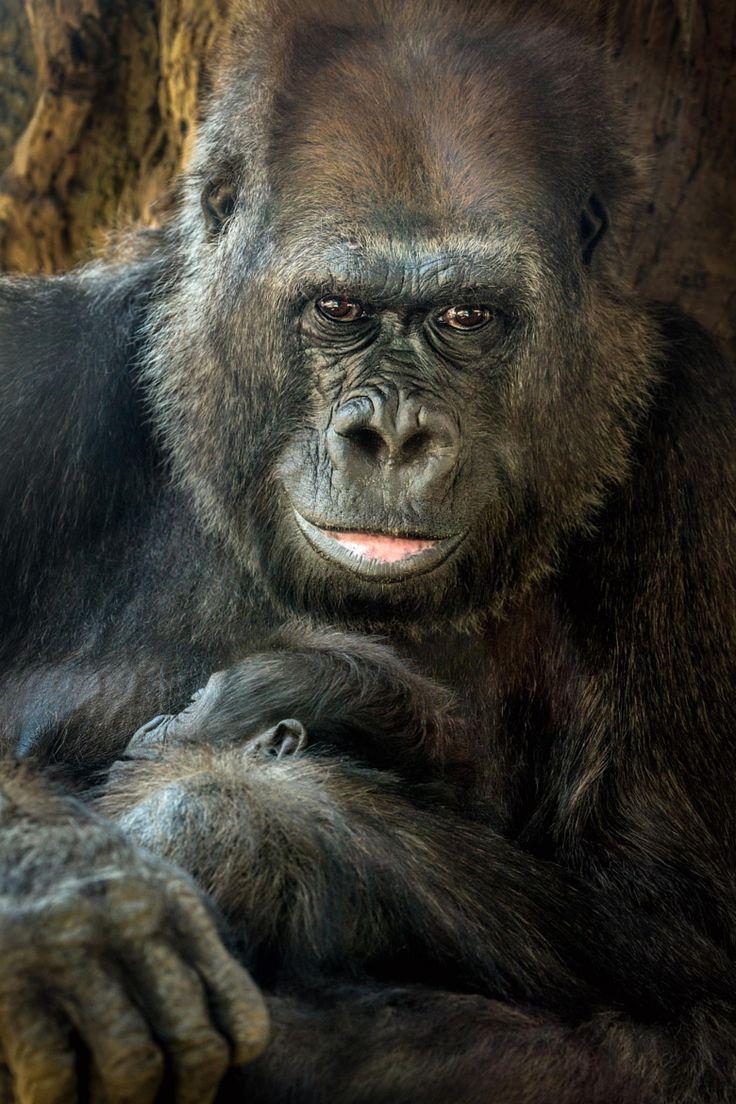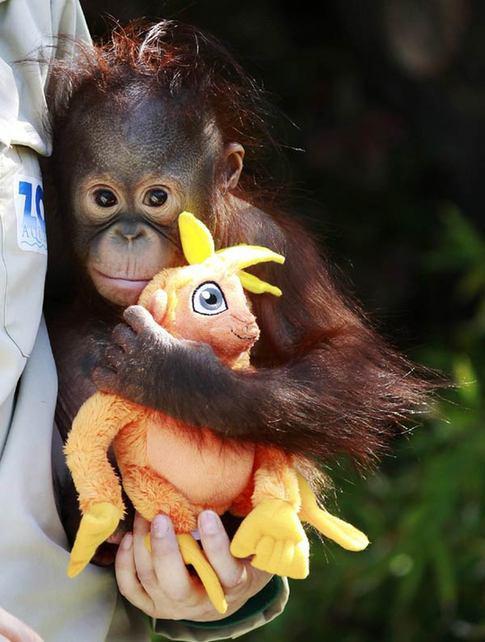The first image is the image on the left, the second image is the image on the right. Considering the images on both sides, is "In at least one image there are two gorilla one adult holding a single baby." valid? Answer yes or no. Yes. The first image is the image on the left, the second image is the image on the right. Given the left and right images, does the statement "One image shows an adult gorilla cradling a baby gorilla at its chest with at least one arm." hold true? Answer yes or no. Yes. 